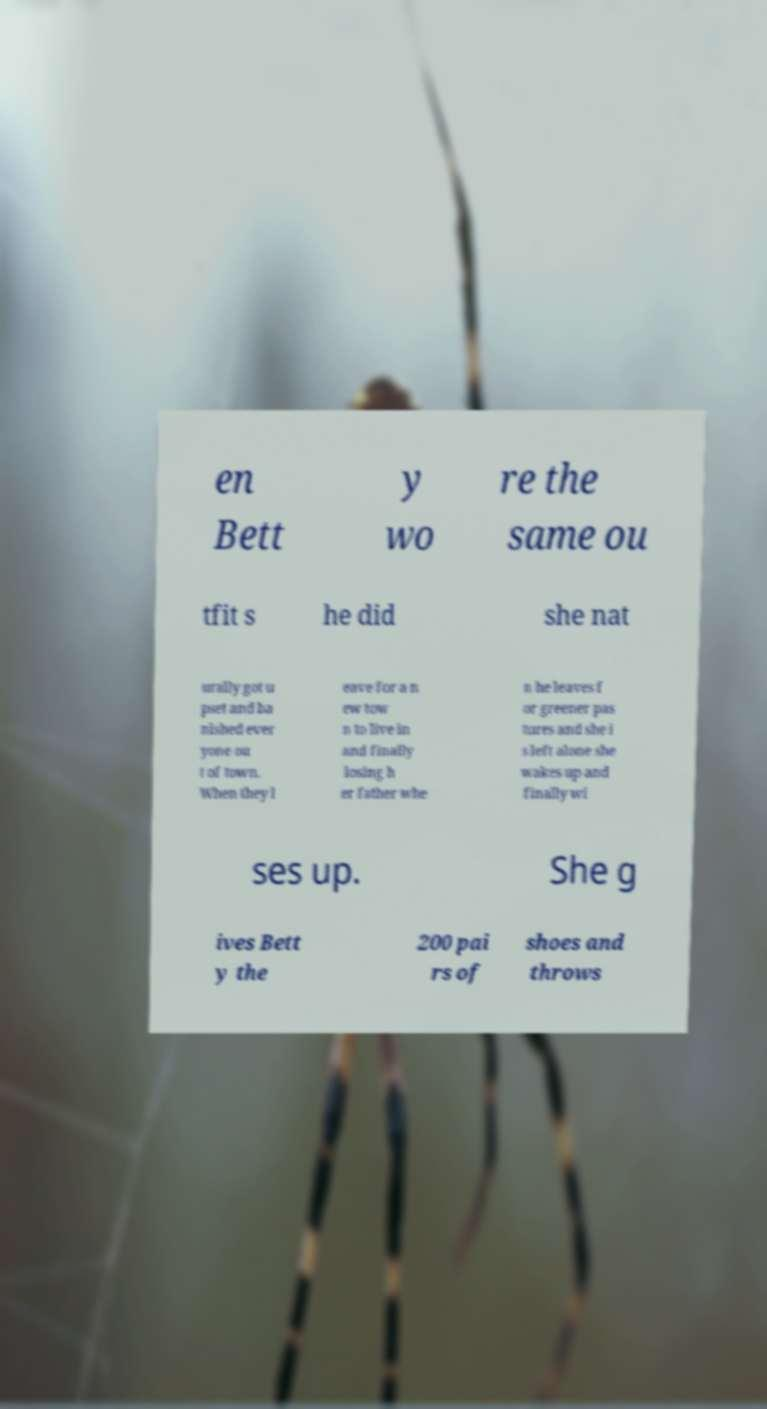There's text embedded in this image that I need extracted. Can you transcribe it verbatim? en Bett y wo re the same ou tfit s he did she nat urally got u pset and ba nished ever yone ou t of town. When they l eave for a n ew tow n to live in and finally losing h er father whe n he leaves f or greener pas tures and she i s left alone she wakes up and finally wi ses up. She g ives Bett y the 200 pai rs of shoes and throws 